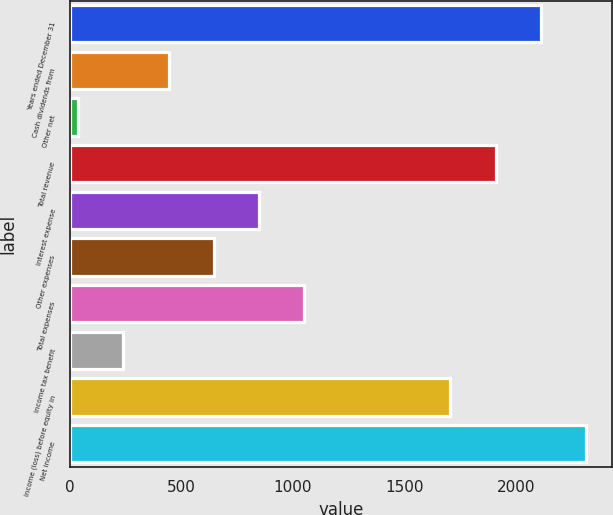Convert chart to OTSL. <chart><loc_0><loc_0><loc_500><loc_500><bar_chart><fcel>Years ended December 31<fcel>Cash dividends from<fcel>Other net<fcel>Total revenue<fcel>Interest expense<fcel>Other expenses<fcel>Total expenses<fcel>Income tax benefit<fcel>Income (loss) before equity in<fcel>Net income<nl><fcel>2110.6<fcel>442.6<fcel>38<fcel>1908.3<fcel>847.2<fcel>644.9<fcel>1049.5<fcel>240.3<fcel>1706<fcel>2312.9<nl></chart> 